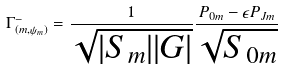<formula> <loc_0><loc_0><loc_500><loc_500>\Gamma _ { ( m , \psi _ { m } ) } ^ { - } = \frac { 1 } { \sqrt { | S _ { m } | | G | } } \frac { P _ { 0 m } - \epsilon P _ { J m } } { \sqrt { S _ { 0 m } } }</formula> 